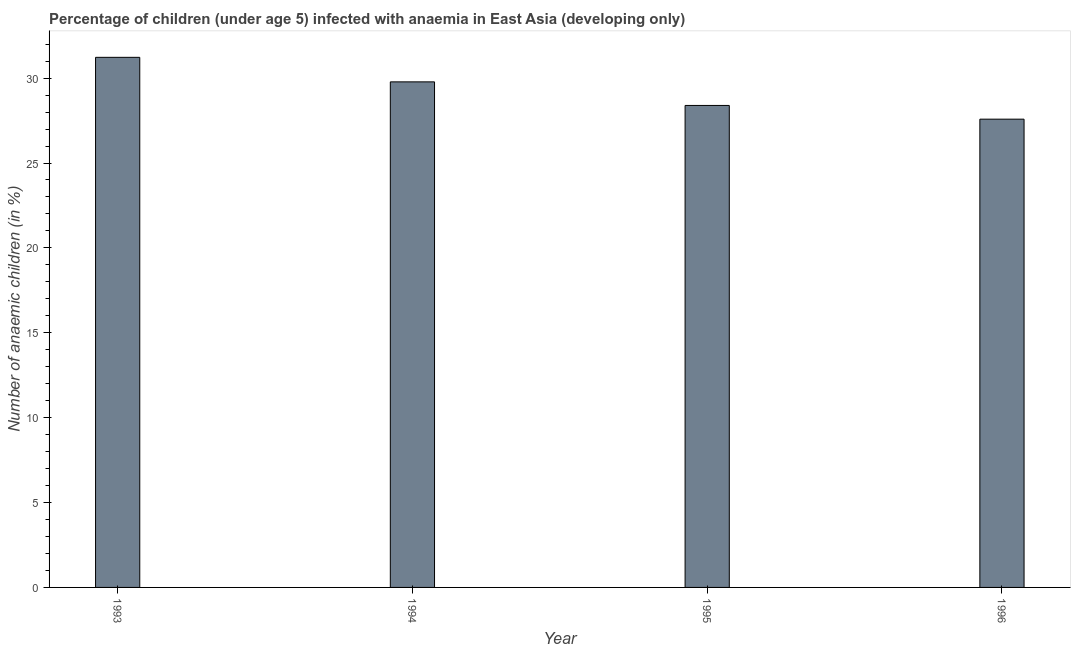Does the graph contain grids?
Offer a terse response. No. What is the title of the graph?
Make the answer very short. Percentage of children (under age 5) infected with anaemia in East Asia (developing only). What is the label or title of the X-axis?
Keep it short and to the point. Year. What is the label or title of the Y-axis?
Provide a short and direct response. Number of anaemic children (in %). What is the number of anaemic children in 1996?
Provide a short and direct response. 27.58. Across all years, what is the maximum number of anaemic children?
Provide a succinct answer. 31.23. Across all years, what is the minimum number of anaemic children?
Give a very brief answer. 27.58. In which year was the number of anaemic children maximum?
Your answer should be compact. 1993. In which year was the number of anaemic children minimum?
Your answer should be very brief. 1996. What is the sum of the number of anaemic children?
Your answer should be compact. 116.98. What is the difference between the number of anaemic children in 1995 and 1996?
Your response must be concise. 0.81. What is the average number of anaemic children per year?
Offer a very short reply. 29.25. What is the median number of anaemic children?
Provide a succinct answer. 29.09. Do a majority of the years between 1993 and 1996 (inclusive) have number of anaemic children greater than 29 %?
Your answer should be very brief. No. Is the number of anaemic children in 1995 less than that in 1996?
Your answer should be compact. No. Is the difference between the number of anaemic children in 1993 and 1995 greater than the difference between any two years?
Keep it short and to the point. No. What is the difference between the highest and the second highest number of anaemic children?
Keep it short and to the point. 1.45. Is the sum of the number of anaemic children in 1995 and 1996 greater than the maximum number of anaemic children across all years?
Ensure brevity in your answer.  Yes. What is the difference between the highest and the lowest number of anaemic children?
Your answer should be very brief. 3.64. How many bars are there?
Give a very brief answer. 4. Are all the bars in the graph horizontal?
Ensure brevity in your answer.  No. What is the Number of anaemic children (in %) of 1993?
Offer a terse response. 31.23. What is the Number of anaemic children (in %) of 1994?
Your answer should be very brief. 29.78. What is the Number of anaemic children (in %) in 1995?
Your response must be concise. 28.39. What is the Number of anaemic children (in %) of 1996?
Make the answer very short. 27.58. What is the difference between the Number of anaemic children (in %) in 1993 and 1994?
Provide a short and direct response. 1.45. What is the difference between the Number of anaemic children (in %) in 1993 and 1995?
Ensure brevity in your answer.  2.83. What is the difference between the Number of anaemic children (in %) in 1993 and 1996?
Offer a terse response. 3.64. What is the difference between the Number of anaemic children (in %) in 1994 and 1995?
Provide a succinct answer. 1.39. What is the difference between the Number of anaemic children (in %) in 1994 and 1996?
Offer a very short reply. 2.2. What is the difference between the Number of anaemic children (in %) in 1995 and 1996?
Ensure brevity in your answer.  0.81. What is the ratio of the Number of anaemic children (in %) in 1993 to that in 1994?
Provide a short and direct response. 1.05. What is the ratio of the Number of anaemic children (in %) in 1993 to that in 1996?
Your response must be concise. 1.13. What is the ratio of the Number of anaemic children (in %) in 1994 to that in 1995?
Make the answer very short. 1.05. 